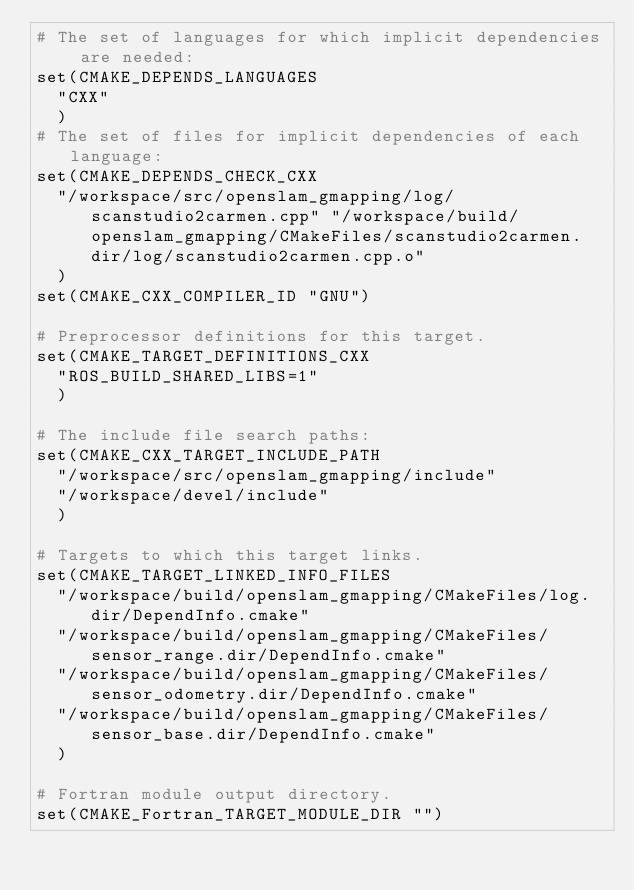Convert code to text. <code><loc_0><loc_0><loc_500><loc_500><_CMake_># The set of languages for which implicit dependencies are needed:
set(CMAKE_DEPENDS_LANGUAGES
  "CXX"
  )
# The set of files for implicit dependencies of each language:
set(CMAKE_DEPENDS_CHECK_CXX
  "/workspace/src/openslam_gmapping/log/scanstudio2carmen.cpp" "/workspace/build/openslam_gmapping/CMakeFiles/scanstudio2carmen.dir/log/scanstudio2carmen.cpp.o"
  )
set(CMAKE_CXX_COMPILER_ID "GNU")

# Preprocessor definitions for this target.
set(CMAKE_TARGET_DEFINITIONS_CXX
  "ROS_BUILD_SHARED_LIBS=1"
  )

# The include file search paths:
set(CMAKE_CXX_TARGET_INCLUDE_PATH
  "/workspace/src/openslam_gmapping/include"
  "/workspace/devel/include"
  )

# Targets to which this target links.
set(CMAKE_TARGET_LINKED_INFO_FILES
  "/workspace/build/openslam_gmapping/CMakeFiles/log.dir/DependInfo.cmake"
  "/workspace/build/openslam_gmapping/CMakeFiles/sensor_range.dir/DependInfo.cmake"
  "/workspace/build/openslam_gmapping/CMakeFiles/sensor_odometry.dir/DependInfo.cmake"
  "/workspace/build/openslam_gmapping/CMakeFiles/sensor_base.dir/DependInfo.cmake"
  )

# Fortran module output directory.
set(CMAKE_Fortran_TARGET_MODULE_DIR "")
</code> 